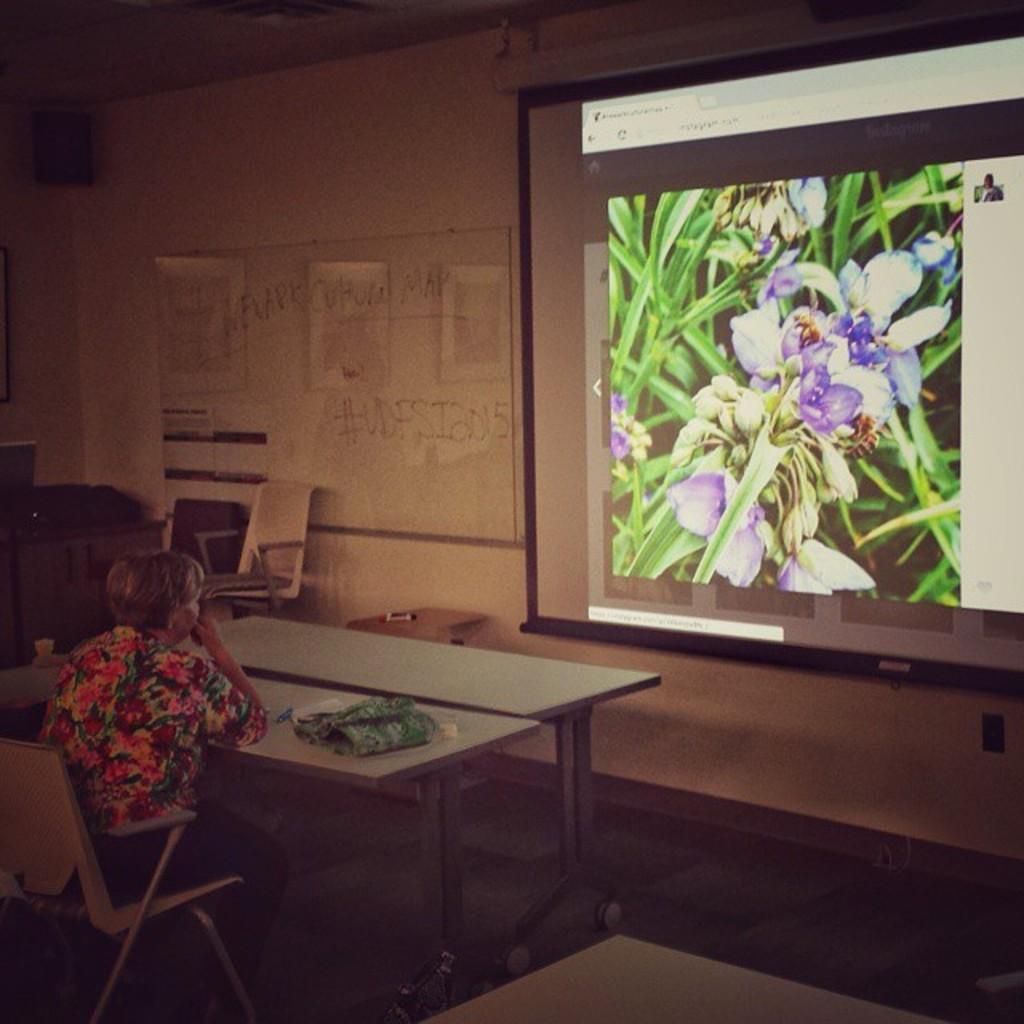How would you summarize this image in a sentence or two? There is a woman on the left side. She is sitting on a chair. There is a table. There is a cloth on a table. We can see in the background posters,wall and projector. 